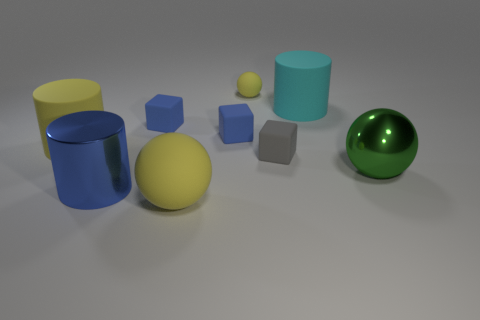Add 1 cyan balls. How many objects exist? 10 Subtract all gray cubes. How many cubes are left? 2 Subtract all blue cubes. How many yellow spheres are left? 2 Subtract all spheres. How many objects are left? 6 Subtract all yellow spheres. How many spheres are left? 1 Subtract all cyan spheres. Subtract all blue cylinders. How many spheres are left? 3 Subtract all big red rubber cylinders. Subtract all large yellow rubber cylinders. How many objects are left? 8 Add 6 large cyan rubber things. How many large cyan rubber things are left? 7 Add 3 yellow rubber things. How many yellow rubber things exist? 6 Subtract 0 brown spheres. How many objects are left? 9 